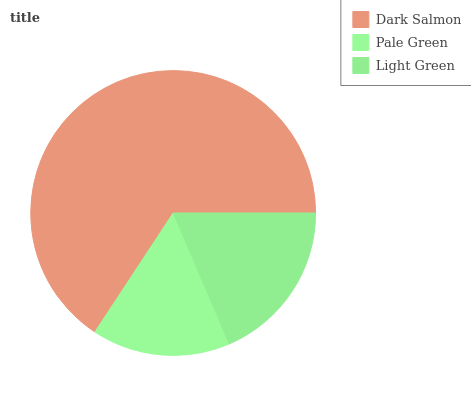Is Pale Green the minimum?
Answer yes or no. Yes. Is Dark Salmon the maximum?
Answer yes or no. Yes. Is Light Green the minimum?
Answer yes or no. No. Is Light Green the maximum?
Answer yes or no. No. Is Light Green greater than Pale Green?
Answer yes or no. Yes. Is Pale Green less than Light Green?
Answer yes or no. Yes. Is Pale Green greater than Light Green?
Answer yes or no. No. Is Light Green less than Pale Green?
Answer yes or no. No. Is Light Green the high median?
Answer yes or no. Yes. Is Light Green the low median?
Answer yes or no. Yes. Is Dark Salmon the high median?
Answer yes or no. No. Is Dark Salmon the low median?
Answer yes or no. No. 